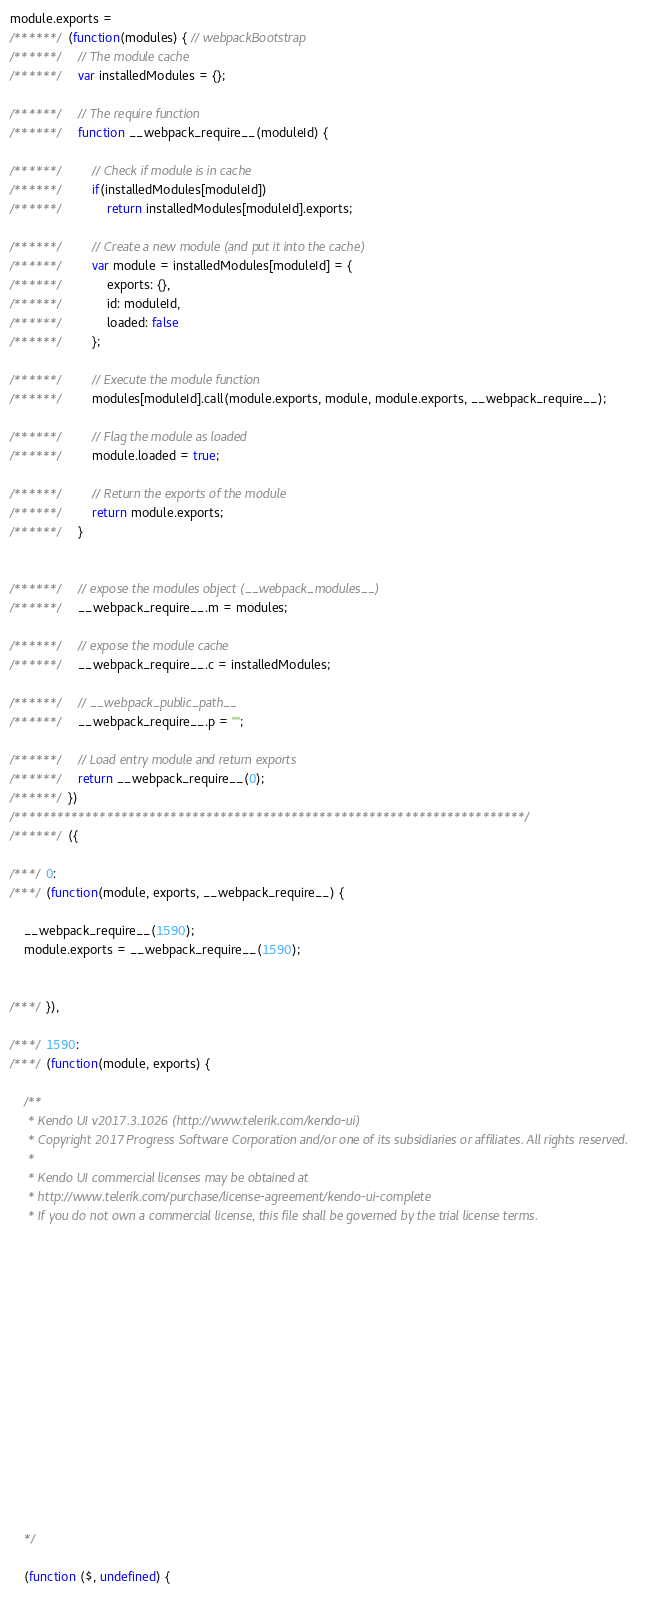Convert code to text. <code><loc_0><loc_0><loc_500><loc_500><_JavaScript_>module.exports =
/******/ (function(modules) { // webpackBootstrap
/******/ 	// The module cache
/******/ 	var installedModules = {};

/******/ 	// The require function
/******/ 	function __webpack_require__(moduleId) {

/******/ 		// Check if module is in cache
/******/ 		if(installedModules[moduleId])
/******/ 			return installedModules[moduleId].exports;

/******/ 		// Create a new module (and put it into the cache)
/******/ 		var module = installedModules[moduleId] = {
/******/ 			exports: {},
/******/ 			id: moduleId,
/******/ 			loaded: false
/******/ 		};

/******/ 		// Execute the module function
/******/ 		modules[moduleId].call(module.exports, module, module.exports, __webpack_require__);

/******/ 		// Flag the module as loaded
/******/ 		module.loaded = true;

/******/ 		// Return the exports of the module
/******/ 		return module.exports;
/******/ 	}


/******/ 	// expose the modules object (__webpack_modules__)
/******/ 	__webpack_require__.m = modules;

/******/ 	// expose the module cache
/******/ 	__webpack_require__.c = installedModules;

/******/ 	// __webpack_public_path__
/******/ 	__webpack_require__.p = "";

/******/ 	// Load entry module and return exports
/******/ 	return __webpack_require__(0);
/******/ })
/************************************************************************/
/******/ ({

/***/ 0:
/***/ (function(module, exports, __webpack_require__) {

	__webpack_require__(1590);
	module.exports = __webpack_require__(1590);


/***/ }),

/***/ 1590:
/***/ (function(module, exports) {

	/**
	 * Kendo UI v2017.3.1026 (http://www.telerik.com/kendo-ui)
	 * Copyright 2017 Progress Software Corporation and/or one of its subsidiaries or affiliates. All rights reserved.
	 *
	 * Kendo UI commercial licenses may be obtained at
	 * http://www.telerik.com/purchase/license-agreement/kendo-ui-complete
	 * If you do not own a commercial license, this file shall be governed by the trial license terms.
















	*/

	(function ($, undefined) {</code> 